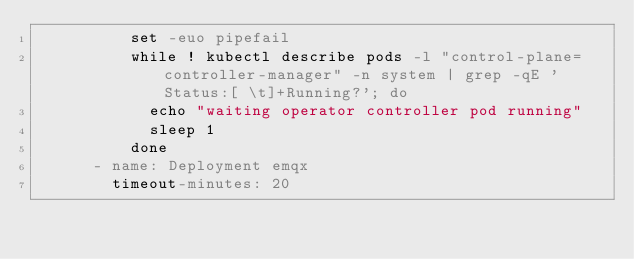<code> <loc_0><loc_0><loc_500><loc_500><_YAML_>          set -euo pipefail
          while ! kubectl describe pods -l "control-plane=controller-manager" -n system | grep -qE 'Status:[ \t]+Running?'; do
            echo "waiting operator controller pod running"
            sleep 1
          done
      - name: Deployment emqx
        timeout-minutes: 20</code> 